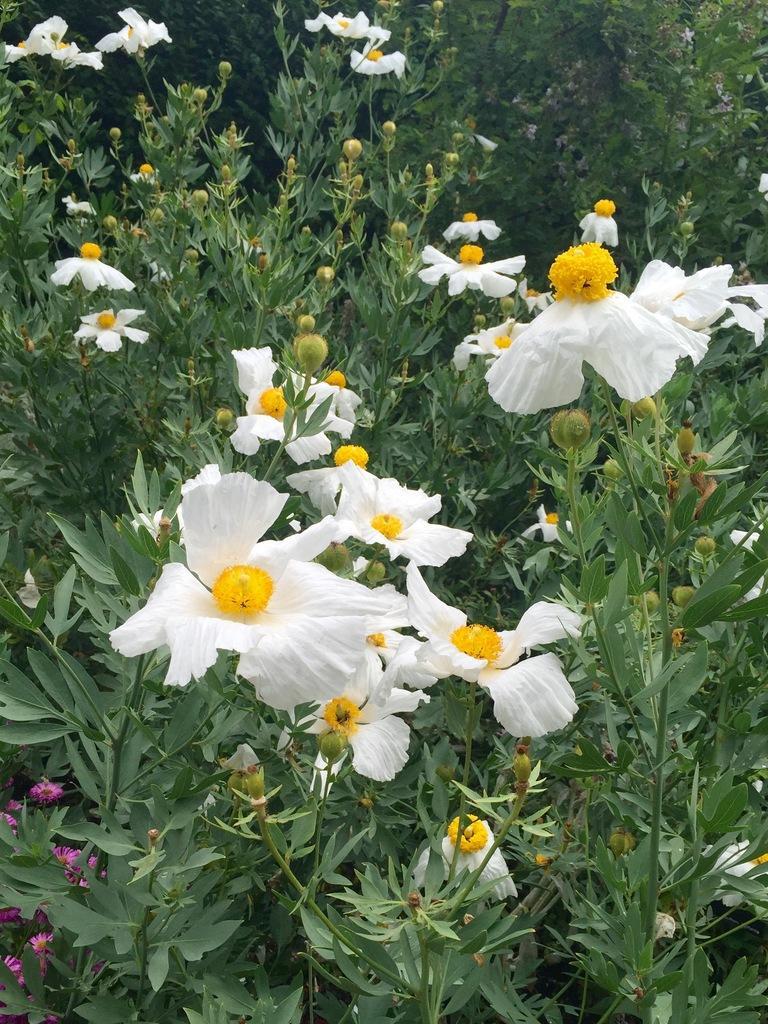In one or two sentences, can you explain what this image depicts? In this given picture, We can see a white and pink color flowers which include with stem after that, We can see certain trees. 